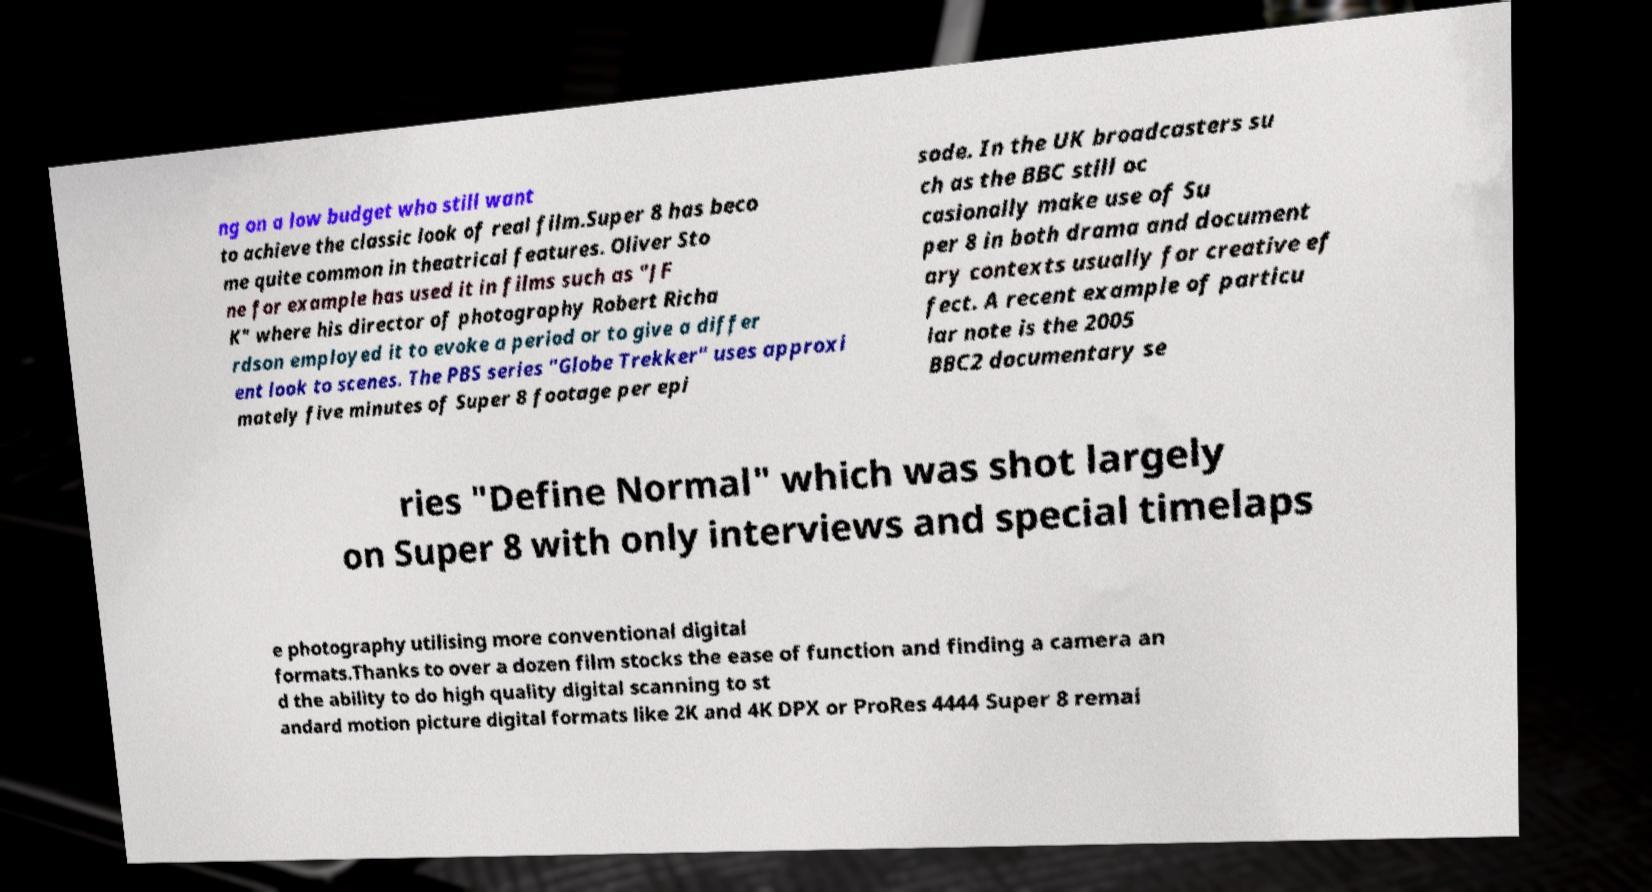Please read and relay the text visible in this image. What does it say? ng on a low budget who still want to achieve the classic look of real film.Super 8 has beco me quite common in theatrical features. Oliver Sto ne for example has used it in films such as "JF K" where his director of photography Robert Richa rdson employed it to evoke a period or to give a differ ent look to scenes. The PBS series "Globe Trekker" uses approxi mately five minutes of Super 8 footage per epi sode. In the UK broadcasters su ch as the BBC still oc casionally make use of Su per 8 in both drama and document ary contexts usually for creative ef fect. A recent example of particu lar note is the 2005 BBC2 documentary se ries "Define Normal" which was shot largely on Super 8 with only interviews and special timelaps e photography utilising more conventional digital formats.Thanks to over a dozen film stocks the ease of function and finding a camera an d the ability to do high quality digital scanning to st andard motion picture digital formats like 2K and 4K DPX or ProRes 4444 Super 8 remai 